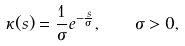Convert formula to latex. <formula><loc_0><loc_0><loc_500><loc_500>\kappa ( s ) = \frac { 1 } { \sigma } e ^ { - \frac { s } { \sigma } } , \quad \sigma > 0 ,</formula> 